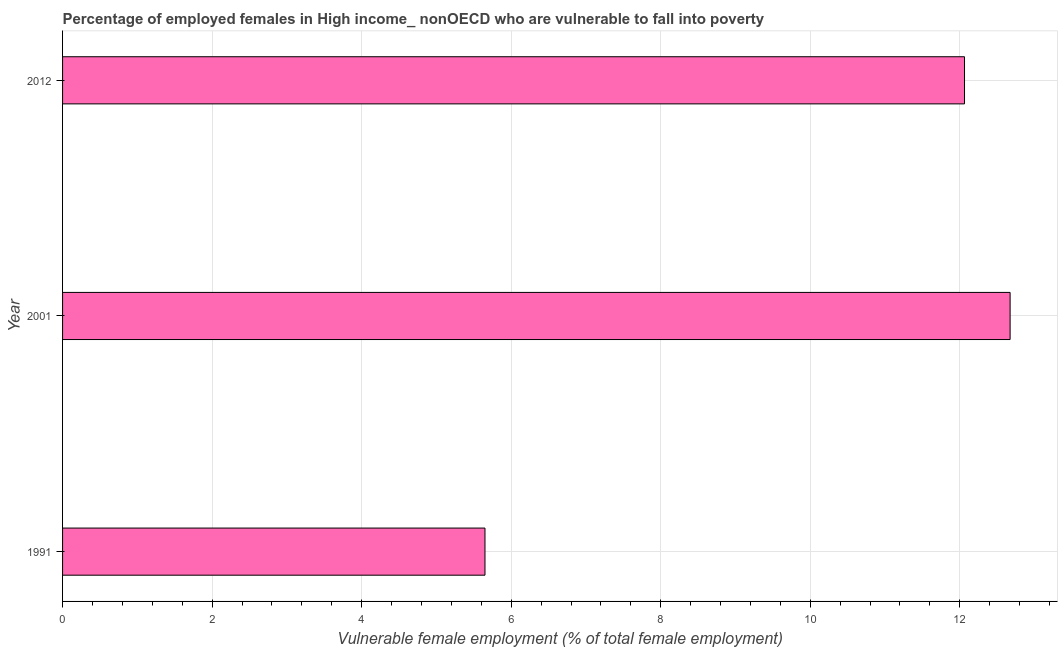What is the title of the graph?
Provide a succinct answer. Percentage of employed females in High income_ nonOECD who are vulnerable to fall into poverty. What is the label or title of the X-axis?
Offer a terse response. Vulnerable female employment (% of total female employment). What is the percentage of employed females who are vulnerable to fall into poverty in 2012?
Keep it short and to the point. 12.06. Across all years, what is the maximum percentage of employed females who are vulnerable to fall into poverty?
Your response must be concise. 12.67. Across all years, what is the minimum percentage of employed females who are vulnerable to fall into poverty?
Offer a terse response. 5.65. In which year was the percentage of employed females who are vulnerable to fall into poverty maximum?
Provide a succinct answer. 2001. In which year was the percentage of employed females who are vulnerable to fall into poverty minimum?
Offer a very short reply. 1991. What is the sum of the percentage of employed females who are vulnerable to fall into poverty?
Your response must be concise. 30.39. What is the difference between the percentage of employed females who are vulnerable to fall into poverty in 1991 and 2001?
Ensure brevity in your answer.  -7.02. What is the average percentage of employed females who are vulnerable to fall into poverty per year?
Keep it short and to the point. 10.13. What is the median percentage of employed females who are vulnerable to fall into poverty?
Your answer should be compact. 12.06. What is the ratio of the percentage of employed females who are vulnerable to fall into poverty in 1991 to that in 2012?
Your answer should be compact. 0.47. Is the difference between the percentage of employed females who are vulnerable to fall into poverty in 1991 and 2001 greater than the difference between any two years?
Ensure brevity in your answer.  Yes. What is the difference between the highest and the second highest percentage of employed females who are vulnerable to fall into poverty?
Your response must be concise. 0.61. What is the difference between the highest and the lowest percentage of employed females who are vulnerable to fall into poverty?
Keep it short and to the point. 7.02. How many bars are there?
Your answer should be compact. 3. Are the values on the major ticks of X-axis written in scientific E-notation?
Keep it short and to the point. No. What is the Vulnerable female employment (% of total female employment) in 1991?
Keep it short and to the point. 5.65. What is the Vulnerable female employment (% of total female employment) of 2001?
Offer a very short reply. 12.67. What is the Vulnerable female employment (% of total female employment) of 2012?
Keep it short and to the point. 12.06. What is the difference between the Vulnerable female employment (% of total female employment) in 1991 and 2001?
Your answer should be very brief. -7.02. What is the difference between the Vulnerable female employment (% of total female employment) in 1991 and 2012?
Offer a terse response. -6.41. What is the difference between the Vulnerable female employment (% of total female employment) in 2001 and 2012?
Provide a short and direct response. 0.61. What is the ratio of the Vulnerable female employment (% of total female employment) in 1991 to that in 2001?
Provide a short and direct response. 0.45. What is the ratio of the Vulnerable female employment (% of total female employment) in 1991 to that in 2012?
Your response must be concise. 0.47. What is the ratio of the Vulnerable female employment (% of total female employment) in 2001 to that in 2012?
Keep it short and to the point. 1.05. 